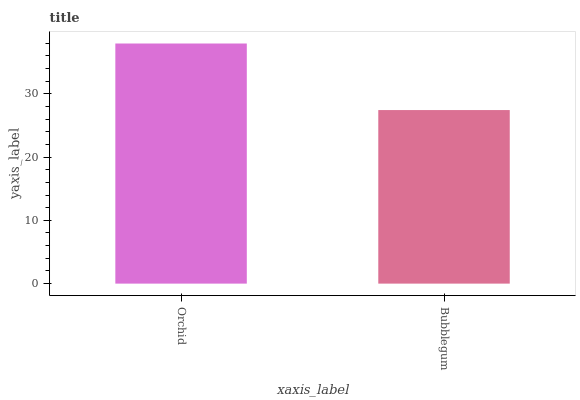Is Bubblegum the maximum?
Answer yes or no. No. Is Orchid greater than Bubblegum?
Answer yes or no. Yes. Is Bubblegum less than Orchid?
Answer yes or no. Yes. Is Bubblegum greater than Orchid?
Answer yes or no. No. Is Orchid less than Bubblegum?
Answer yes or no. No. Is Orchid the high median?
Answer yes or no. Yes. Is Bubblegum the low median?
Answer yes or no. Yes. Is Bubblegum the high median?
Answer yes or no. No. Is Orchid the low median?
Answer yes or no. No. 